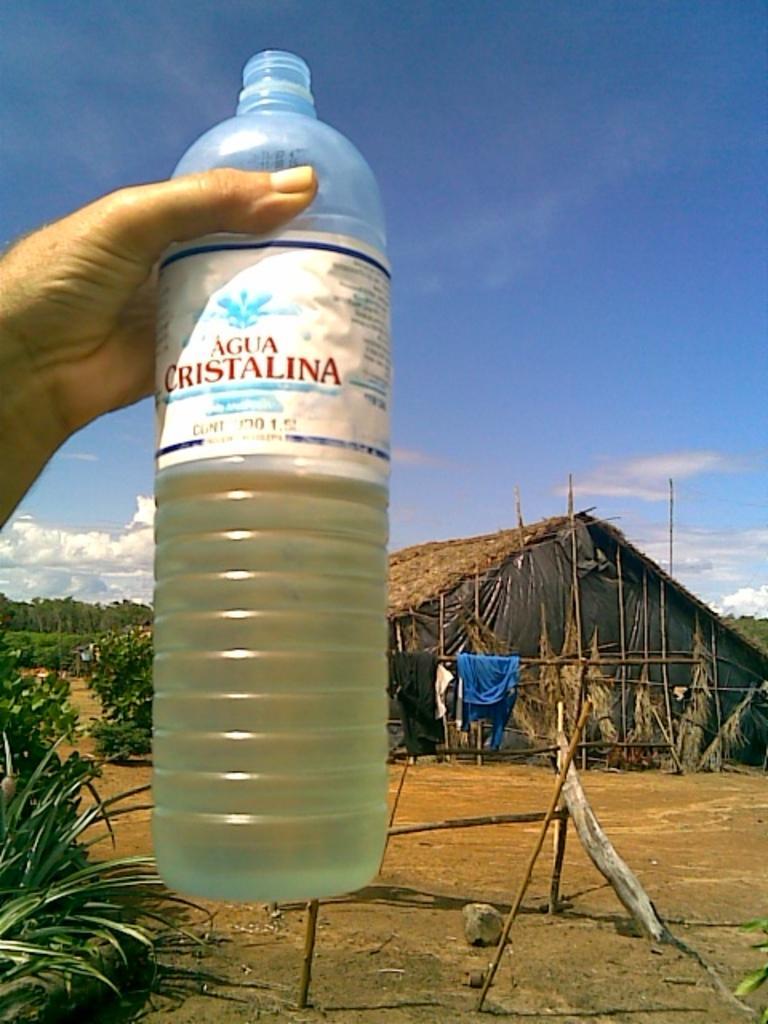In one or two sentences, can you explain what this image depicts? In the image,there is a bottle,a hand holding the bottle it looks like a man's hand,in the background there is a hut and there are some clothes hanged to the pole and there are some other trees and plants and there is also sky and some clouds. 